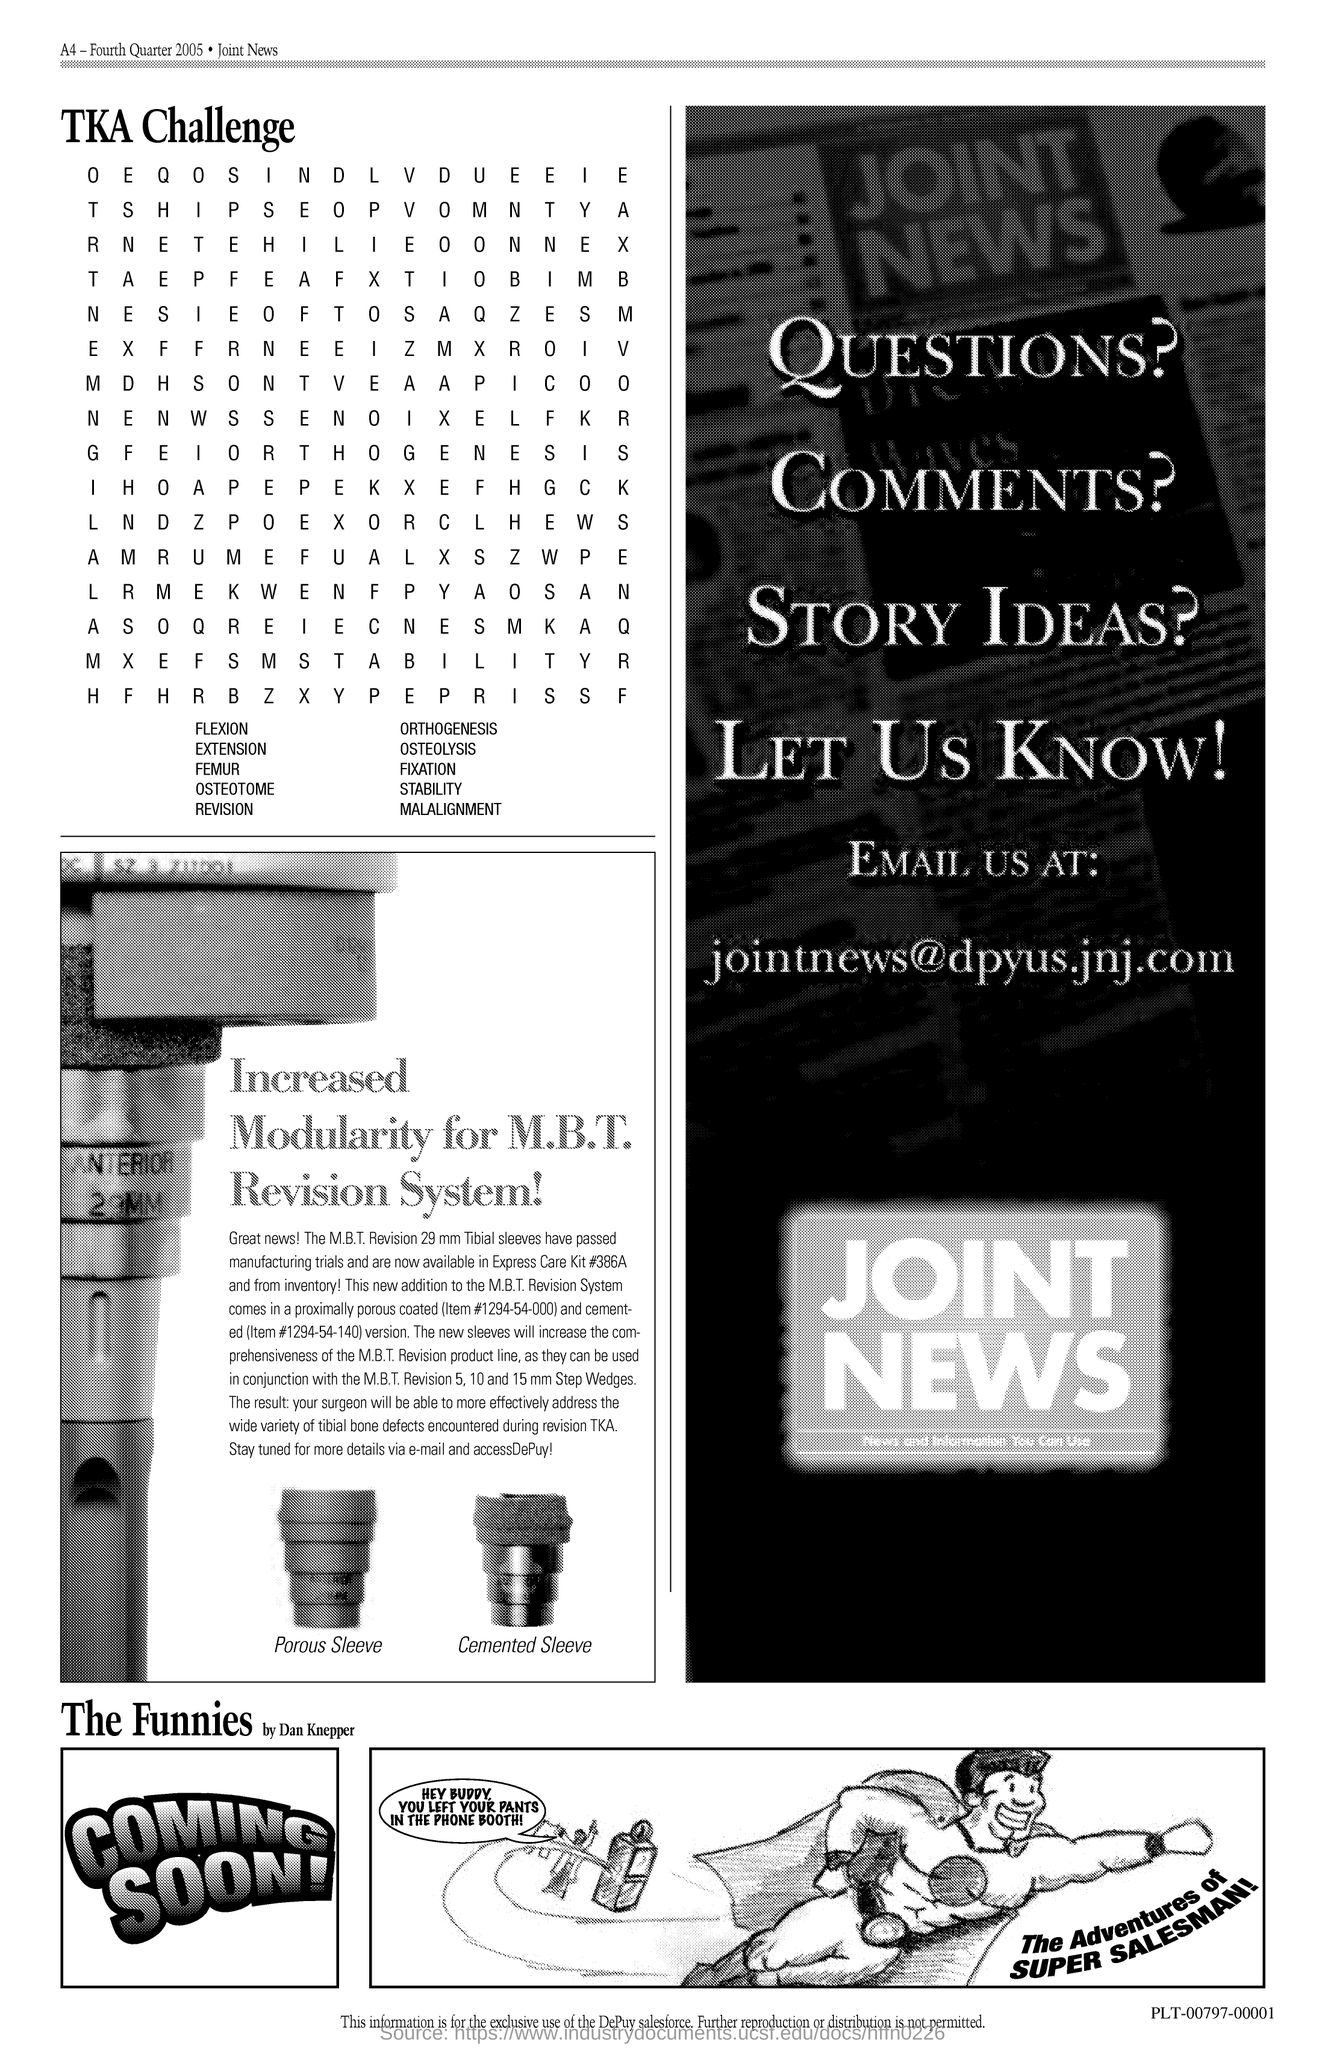Mention a couple of crucial points in this snapshot. The title written above the alphabet is "TKA Challenge. 